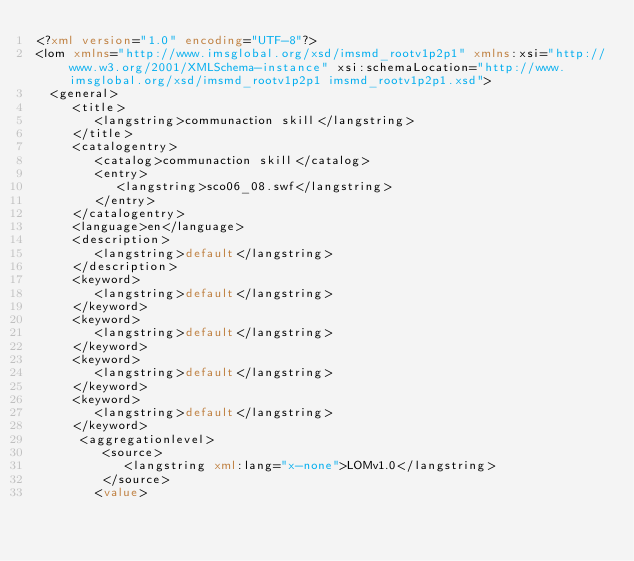<code> <loc_0><loc_0><loc_500><loc_500><_XML_><?xml version="1.0" encoding="UTF-8"?>
<lom xmlns="http://www.imsglobal.org/xsd/imsmd_rootv1p2p1" xmlns:xsi="http://www.w3.org/2001/XMLSchema-instance" xsi:schemaLocation="http://www.imsglobal.org/xsd/imsmd_rootv1p2p1 imsmd_rootv1p2p1.xsd">
	<general>
	   <title>
	      <langstring>communaction skill</langstring>
	   </title>
	   <catalogentry>
	      <catalog>communaction skill</catalog>
	      <entry>
	         <langstring>sco06_08.swf</langstring>
	      </entry>
	   </catalogentry>
	   <language>en</language>
	   <description>
	      <langstring>default</langstring>
	   </description>
	   <keyword>
	      <langstring>default</langstring>
	   </keyword>
	   <keyword>
	      <langstring>default</langstring>
	   </keyword>
	   <keyword>
	      <langstring>default</langstring>
	   </keyword>
	   <keyword>
	      <langstring>default</langstring>
	   </keyword>
      <aggregationlevel>
         <source>
            <langstring xml:lang="x-none">LOMv1.0</langstring>
         </source>
	      <value></code> 